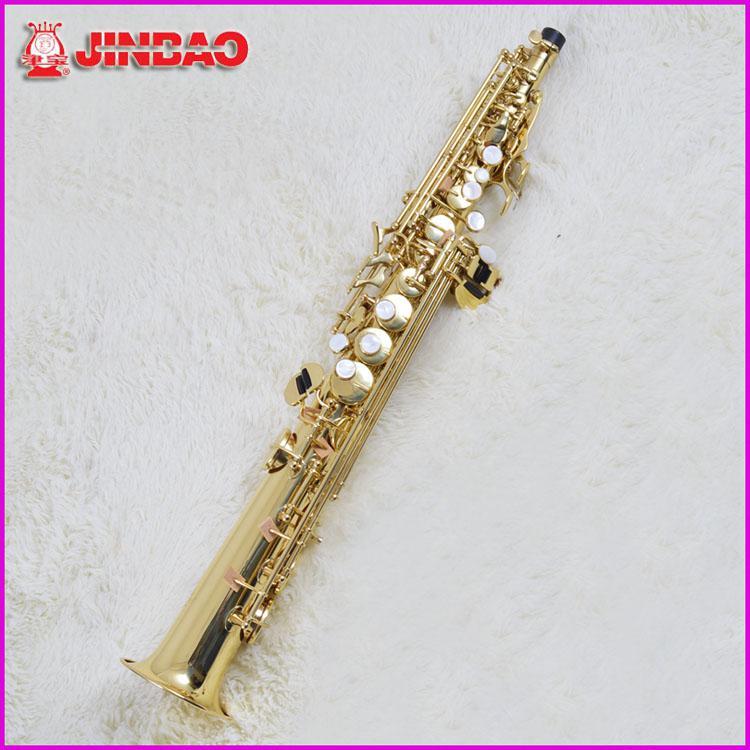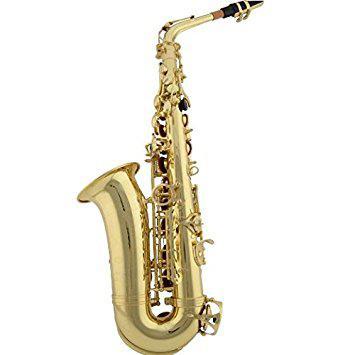The first image is the image on the left, the second image is the image on the right. Considering the images on both sides, is "There are exactly two saxophones with their mouthpiece pointing to the left." valid? Answer yes or no. No. The first image is the image on the left, the second image is the image on the right. Considering the images on both sides, is "Each image contains one saxophone displayed with its bell facing rightward and its mouthpiece pointing leftward, and each saxophone has a curved bell end." valid? Answer yes or no. No. 